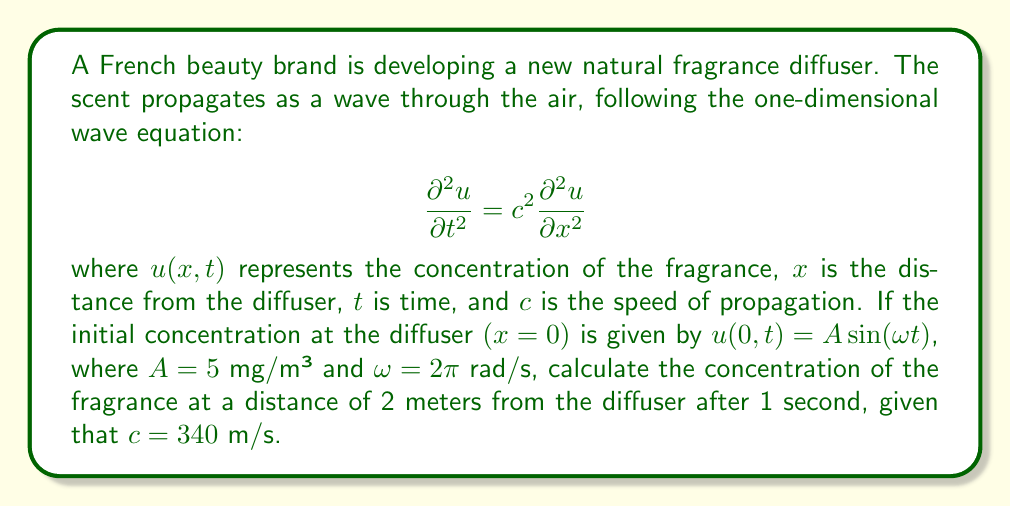Provide a solution to this math problem. To solve this problem, we need to use the general solution for the one-dimensional wave equation with a sinusoidal source:

$$u(x,t) = A \sin(\omega t - kx)$$

where $k$ is the wave number.

Step 1: Calculate the wave number $k$
The wave number is related to the angular frequency $\omega$ and the speed of propagation $c$ by:
$$k = \frac{\omega}{c}$$

$$k = \frac{2\pi}{340} \approx 0.0185 \text{ m}^{-1}$$

Step 2: Substitute the values into the general solution
We have:
- $A = 5$ mg/m³
- $\omega = 2\pi$ rad/s
- $x = 2$ m
- $t = 1$ s
- $k \approx 0.0185$ m^(-1)

$$u(2,1) = 5 \sin(2\pi \cdot 1 - 0.0185 \cdot 2)$$

Step 3: Calculate the argument of the sine function
$$2\pi \cdot 1 - 0.0185 \cdot 2 \approx 6.2467$$

Step 4: Calculate the final result
$$u(2,1) = 5 \sin(6.2467) \approx 4.9934 \text{ mg/m}³$$
Answer: $4.9934 \text{ mg/m}³$ 